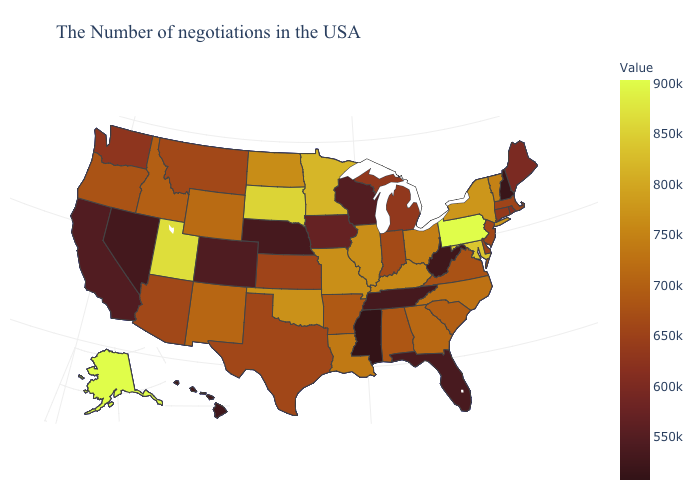Does Kansas have a higher value than Ohio?
Write a very short answer. No. Among the states that border Delaware , does Maryland have the highest value?
Keep it brief. No. Is the legend a continuous bar?
Concise answer only. Yes. Is the legend a continuous bar?
Be succinct. Yes. Does Oklahoma have the highest value in the USA?
Keep it brief. No. 